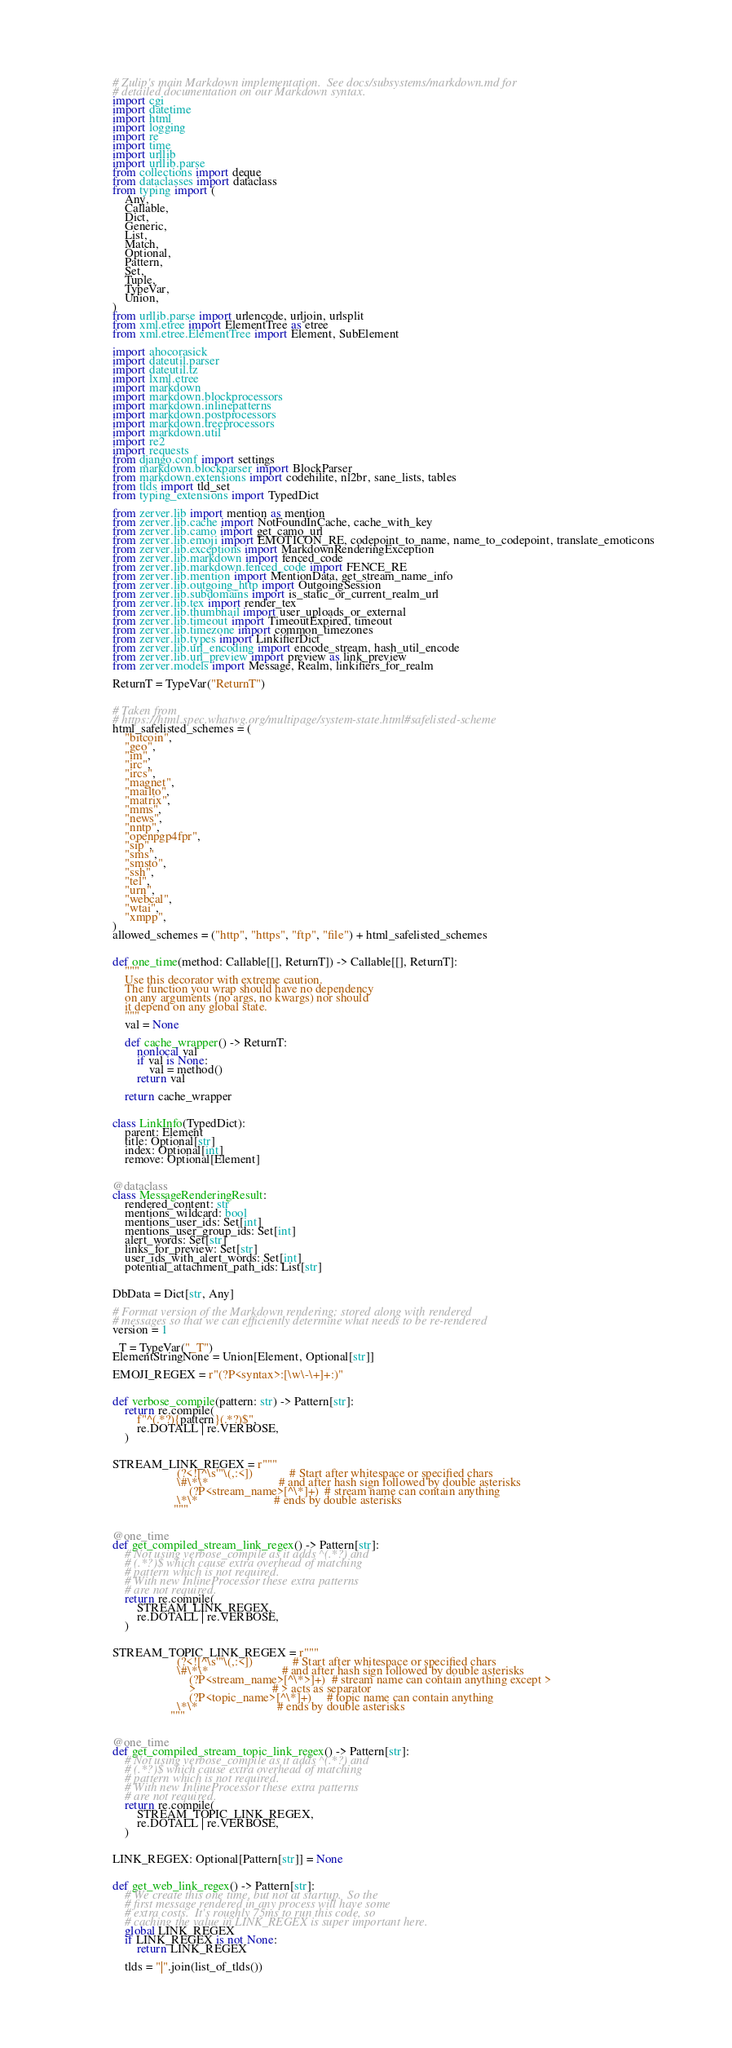<code> <loc_0><loc_0><loc_500><loc_500><_Python_># Zulip's main Markdown implementation.  See docs/subsystems/markdown.md for
# detailed documentation on our Markdown syntax.
import cgi
import datetime
import html
import logging
import re
import time
import urllib
import urllib.parse
from collections import deque
from dataclasses import dataclass
from typing import (
    Any,
    Callable,
    Dict,
    Generic,
    List,
    Match,
    Optional,
    Pattern,
    Set,
    Tuple,
    TypeVar,
    Union,
)
from urllib.parse import urlencode, urljoin, urlsplit
from xml.etree import ElementTree as etree
from xml.etree.ElementTree import Element, SubElement

import ahocorasick
import dateutil.parser
import dateutil.tz
import lxml.etree
import markdown
import markdown.blockprocessors
import markdown.inlinepatterns
import markdown.postprocessors
import markdown.treeprocessors
import markdown.util
import re2
import requests
from django.conf import settings
from markdown.blockparser import BlockParser
from markdown.extensions import codehilite, nl2br, sane_lists, tables
from tlds import tld_set
from typing_extensions import TypedDict

from zerver.lib import mention as mention
from zerver.lib.cache import NotFoundInCache, cache_with_key
from zerver.lib.camo import get_camo_url
from zerver.lib.emoji import EMOTICON_RE, codepoint_to_name, name_to_codepoint, translate_emoticons
from zerver.lib.exceptions import MarkdownRenderingException
from zerver.lib.markdown import fenced_code
from zerver.lib.markdown.fenced_code import FENCE_RE
from zerver.lib.mention import MentionData, get_stream_name_info
from zerver.lib.outgoing_http import OutgoingSession
from zerver.lib.subdomains import is_static_or_current_realm_url
from zerver.lib.tex import render_tex
from zerver.lib.thumbnail import user_uploads_or_external
from zerver.lib.timeout import TimeoutExpired, timeout
from zerver.lib.timezone import common_timezones
from zerver.lib.types import LinkifierDict
from zerver.lib.url_encoding import encode_stream, hash_util_encode
from zerver.lib.url_preview import preview as link_preview
from zerver.models import Message, Realm, linkifiers_for_realm

ReturnT = TypeVar("ReturnT")


# Taken from
# https://html.spec.whatwg.org/multipage/system-state.html#safelisted-scheme
html_safelisted_schemes = (
    "bitcoin",
    "geo",
    "im",
    "irc",
    "ircs",
    "magnet",
    "mailto",
    "matrix",
    "mms",
    "news",
    "nntp",
    "openpgp4fpr",
    "sip",
    "sms",
    "smsto",
    "ssh",
    "tel",
    "urn",
    "webcal",
    "wtai",
    "xmpp",
)
allowed_schemes = ("http", "https", "ftp", "file") + html_safelisted_schemes


def one_time(method: Callable[[], ReturnT]) -> Callable[[], ReturnT]:
    """
    Use this decorator with extreme caution.
    The function you wrap should have no dependency
    on any arguments (no args, no kwargs) nor should
    it depend on any global state.
    """
    val = None

    def cache_wrapper() -> ReturnT:
        nonlocal val
        if val is None:
            val = method()
        return val

    return cache_wrapper


class LinkInfo(TypedDict):
    parent: Element
    title: Optional[str]
    index: Optional[int]
    remove: Optional[Element]


@dataclass
class MessageRenderingResult:
    rendered_content: str
    mentions_wildcard: bool
    mentions_user_ids: Set[int]
    mentions_user_group_ids: Set[int]
    alert_words: Set[str]
    links_for_preview: Set[str]
    user_ids_with_alert_words: Set[int]
    potential_attachment_path_ids: List[str]


DbData = Dict[str, Any]

# Format version of the Markdown rendering; stored along with rendered
# messages so that we can efficiently determine what needs to be re-rendered
version = 1

_T = TypeVar("_T")
ElementStringNone = Union[Element, Optional[str]]

EMOJI_REGEX = r"(?P<syntax>:[\w\-\+]+:)"


def verbose_compile(pattern: str) -> Pattern[str]:
    return re.compile(
        f"^(.*?){pattern}(.*?)$",
        re.DOTALL | re.VERBOSE,
    )


STREAM_LINK_REGEX = r"""
                     (?<![^\s'"\(,:<])            # Start after whitespace or specified chars
                     \#\*\*                       # and after hash sign followed by double asterisks
                         (?P<stream_name>[^\*]+)  # stream name can contain anything
                     \*\*                         # ends by double asterisks
                    """


@one_time
def get_compiled_stream_link_regex() -> Pattern[str]:
    # Not using verbose_compile as it adds ^(.*?) and
    # (.*?)$ which cause extra overhead of matching
    # pattern which is not required.
    # With new InlineProcessor these extra patterns
    # are not required.
    return re.compile(
        STREAM_LINK_REGEX,
        re.DOTALL | re.VERBOSE,
    )


STREAM_TOPIC_LINK_REGEX = r"""
                     (?<![^\s'"\(,:<])             # Start after whitespace or specified chars
                     \#\*\*                        # and after hash sign followed by double asterisks
                         (?P<stream_name>[^\*>]+)  # stream name can contain anything except >
                         >                         # > acts as separator
                         (?P<topic_name>[^\*]+)     # topic name can contain anything
                     \*\*                          # ends by double asterisks
                   """


@one_time
def get_compiled_stream_topic_link_regex() -> Pattern[str]:
    # Not using verbose_compile as it adds ^(.*?) and
    # (.*?)$ which cause extra overhead of matching
    # pattern which is not required.
    # With new InlineProcessor these extra patterns
    # are not required.
    return re.compile(
        STREAM_TOPIC_LINK_REGEX,
        re.DOTALL | re.VERBOSE,
    )


LINK_REGEX: Optional[Pattern[str]] = None


def get_web_link_regex() -> Pattern[str]:
    # We create this one time, but not at startup.  So the
    # first message rendered in any process will have some
    # extra costs.  It's roughly 75ms to run this code, so
    # caching the value in LINK_REGEX is super important here.
    global LINK_REGEX
    if LINK_REGEX is not None:
        return LINK_REGEX

    tlds = "|".join(list_of_tlds())
</code> 